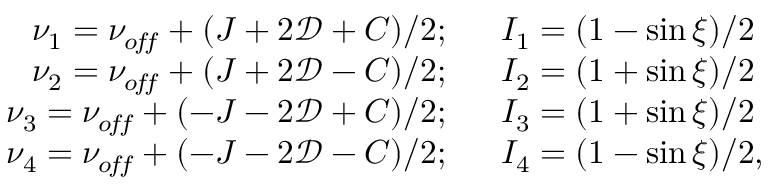Convert formula to latex. <formula><loc_0><loc_0><loc_500><loc_500>\begin{array} { r l } { \nu _ { 1 } = \nu _ { o \, f \, f } + ( J + 2 \mathcal { D } + C ) / 2 ; } & I _ { 1 } = ( 1 - \sin \xi ) / 2 } \\ { \nu _ { 2 } = \nu _ { o \, f \, f } + ( J + 2 \mathcal { D } - C ) / 2 ; } & I _ { 2 } = ( 1 + \sin \xi ) / 2 } \\ { \nu _ { 3 } = \nu _ { o \, f \, f } + ( - J - 2 \mathcal { D } + C ) / 2 ; } & I _ { 3 } = ( 1 + \sin \xi ) / 2 } \\ { \nu _ { 4 } = \nu _ { o \, f \, f } + ( - J - 2 \mathcal { D } - C ) / 2 ; } & I _ { 4 } = ( 1 - \sin \xi ) / 2 , } \end{array}</formula> 